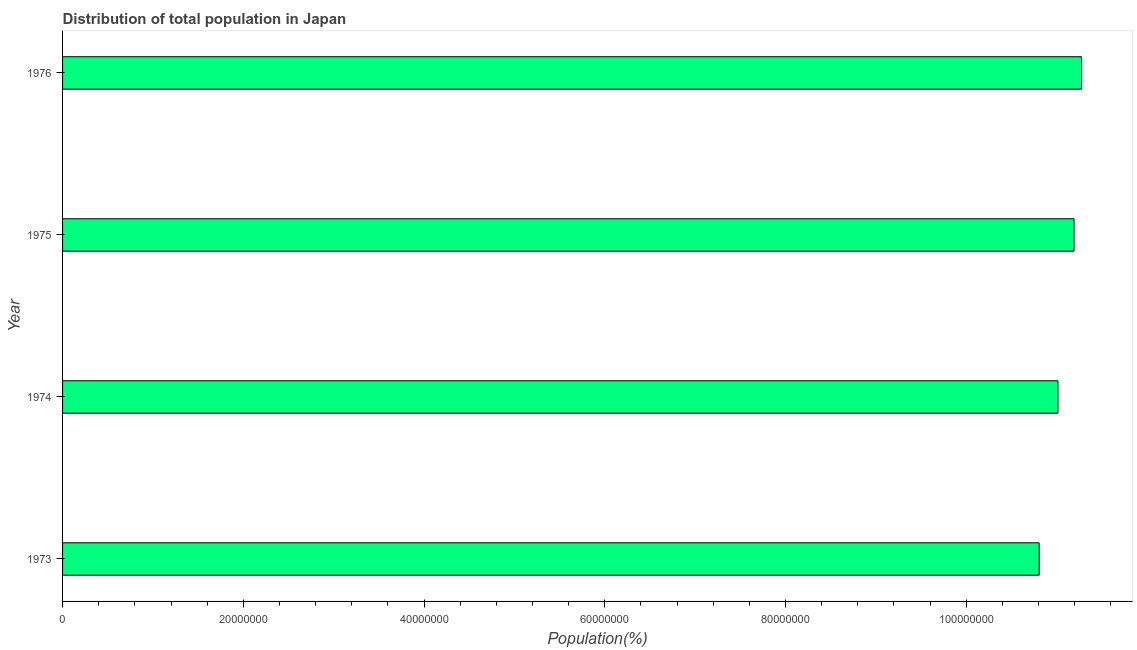What is the title of the graph?
Ensure brevity in your answer.  Distribution of total population in Japan . What is the label or title of the X-axis?
Provide a succinct answer. Population(%). What is the population in 1973?
Ensure brevity in your answer.  1.08e+08. Across all years, what is the maximum population?
Make the answer very short. 1.13e+08. Across all years, what is the minimum population?
Your response must be concise. 1.08e+08. In which year was the population maximum?
Your response must be concise. 1976. In which year was the population minimum?
Ensure brevity in your answer.  1973. What is the sum of the population?
Provide a succinct answer. 4.43e+08. What is the difference between the population in 1974 and 1976?
Give a very brief answer. -2.61e+06. What is the average population per year?
Your answer should be very brief. 1.11e+08. What is the median population?
Offer a very short reply. 1.11e+08. In how many years, is the population greater than 28000000 %?
Offer a very short reply. 4. Do a majority of the years between 1974 and 1973 (inclusive) have population greater than 88000000 %?
Your answer should be compact. No. What is the ratio of the population in 1973 to that in 1975?
Give a very brief answer. 0.97. Is the population in 1974 less than that in 1976?
Offer a very short reply. Yes. What is the difference between the highest and the second highest population?
Your response must be concise. 8.31e+05. Is the sum of the population in 1973 and 1975 greater than the maximum population across all years?
Make the answer very short. Yes. What is the difference between the highest and the lowest population?
Keep it short and to the point. 4.69e+06. In how many years, is the population greater than the average population taken over all years?
Keep it short and to the point. 2. How many bars are there?
Provide a short and direct response. 4. Are all the bars in the graph horizontal?
Give a very brief answer. Yes. How many years are there in the graph?
Offer a very short reply. 4. Are the values on the major ticks of X-axis written in scientific E-notation?
Your response must be concise. No. What is the Population(%) of 1973?
Provide a short and direct response. 1.08e+08. What is the Population(%) of 1974?
Your response must be concise. 1.10e+08. What is the Population(%) of 1975?
Provide a short and direct response. 1.12e+08. What is the Population(%) in 1976?
Offer a very short reply. 1.13e+08. What is the difference between the Population(%) in 1973 and 1974?
Your response must be concise. -2.08e+06. What is the difference between the Population(%) in 1973 and 1975?
Your response must be concise. -3.86e+06. What is the difference between the Population(%) in 1973 and 1976?
Offer a terse response. -4.69e+06. What is the difference between the Population(%) in 1974 and 1975?
Offer a terse response. -1.78e+06. What is the difference between the Population(%) in 1974 and 1976?
Your answer should be compact. -2.61e+06. What is the difference between the Population(%) in 1975 and 1976?
Offer a very short reply. -8.31e+05. What is the ratio of the Population(%) in 1973 to that in 1976?
Provide a short and direct response. 0.96. What is the ratio of the Population(%) in 1974 to that in 1975?
Provide a succinct answer. 0.98. What is the ratio of the Population(%) in 1975 to that in 1976?
Give a very brief answer. 0.99. 